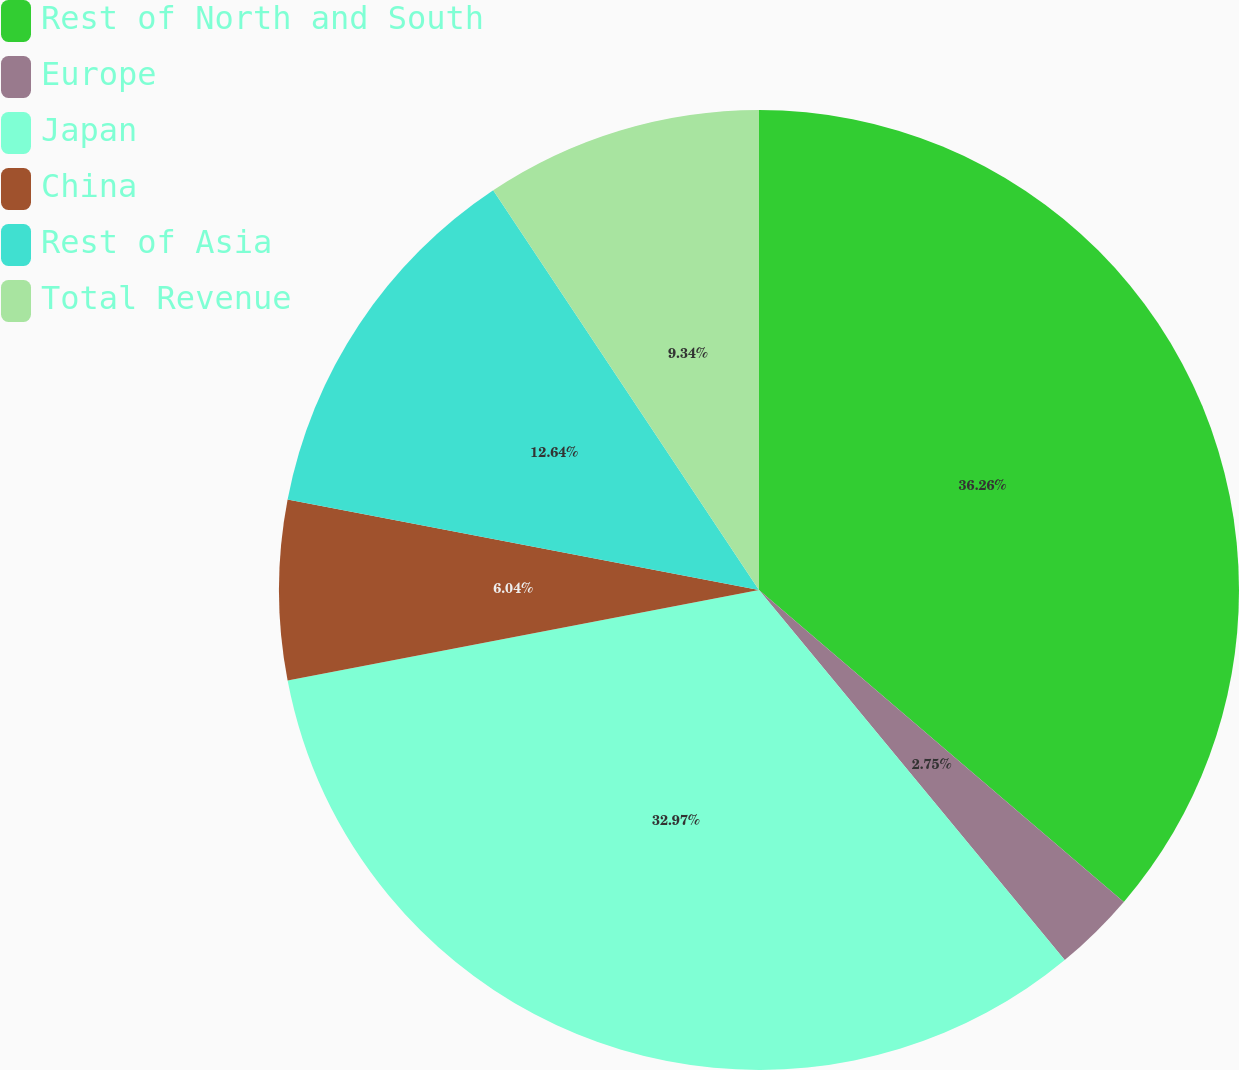Convert chart. <chart><loc_0><loc_0><loc_500><loc_500><pie_chart><fcel>Rest of North and South<fcel>Europe<fcel>Japan<fcel>China<fcel>Rest of Asia<fcel>Total Revenue<nl><fcel>36.26%<fcel>2.75%<fcel>32.97%<fcel>6.04%<fcel>12.64%<fcel>9.34%<nl></chart> 